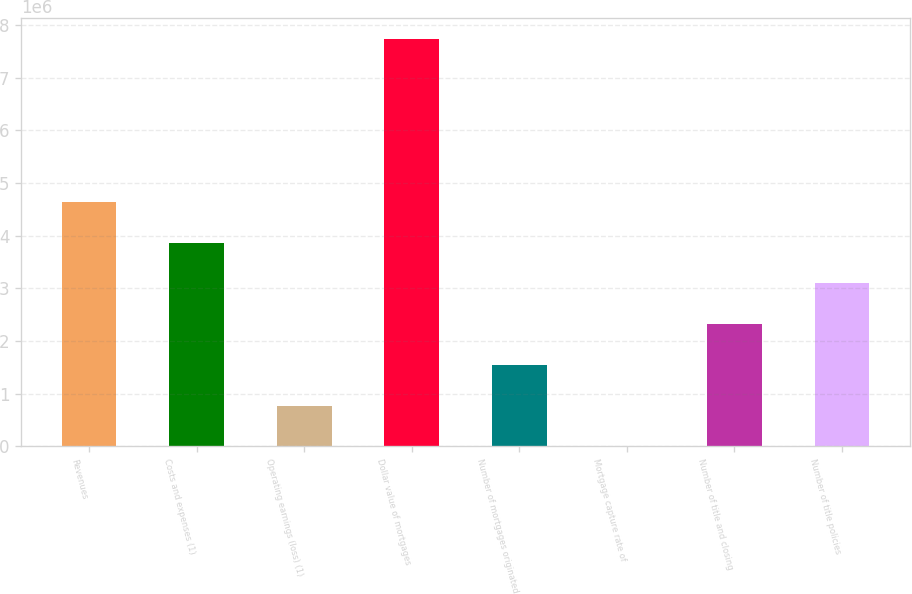Convert chart. <chart><loc_0><loc_0><loc_500><loc_500><bar_chart><fcel>Revenues<fcel>Costs and expenses (1)<fcel>Operating earnings (loss) (1)<fcel>Dollar value of mortgages<fcel>Number of mortgages originated<fcel>Mortgage capture rate of<fcel>Number of title and closing<fcel>Number of title policies<nl><fcel>4.64403e+06<fcel>3.87004e+06<fcel>774066<fcel>7.74e+06<fcel>1.54806e+06<fcel>73<fcel>2.32205e+06<fcel>3.09604e+06<nl></chart> 